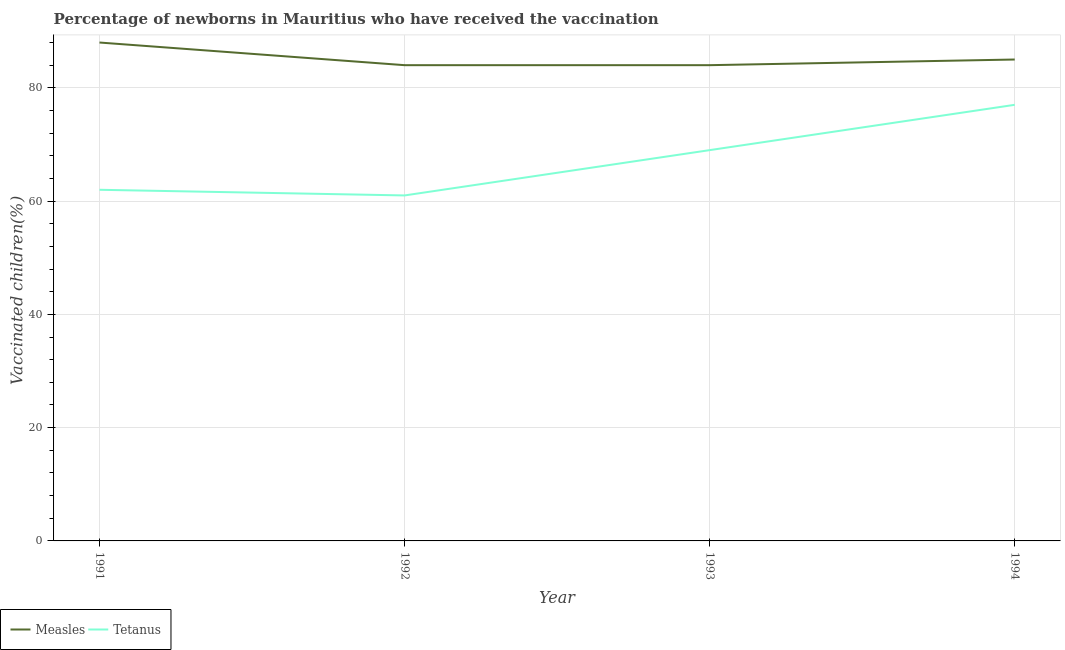How many different coloured lines are there?
Provide a succinct answer. 2. Does the line corresponding to percentage of newborns who received vaccination for measles intersect with the line corresponding to percentage of newborns who received vaccination for tetanus?
Your response must be concise. No. What is the percentage of newborns who received vaccination for measles in 1992?
Give a very brief answer. 84. Across all years, what is the maximum percentage of newborns who received vaccination for tetanus?
Ensure brevity in your answer.  77. Across all years, what is the minimum percentage of newborns who received vaccination for tetanus?
Ensure brevity in your answer.  61. What is the total percentage of newborns who received vaccination for measles in the graph?
Offer a very short reply. 341. What is the difference between the percentage of newborns who received vaccination for measles in 1991 and that in 1993?
Your answer should be compact. 4. What is the difference between the percentage of newborns who received vaccination for measles in 1994 and the percentage of newborns who received vaccination for tetanus in 1992?
Offer a terse response. 24. What is the average percentage of newborns who received vaccination for tetanus per year?
Provide a succinct answer. 67.25. In the year 1992, what is the difference between the percentage of newborns who received vaccination for measles and percentage of newborns who received vaccination for tetanus?
Give a very brief answer. 23. What is the ratio of the percentage of newborns who received vaccination for tetanus in 1991 to that in 1994?
Keep it short and to the point. 0.81. Is the percentage of newborns who received vaccination for measles in 1991 less than that in 1992?
Provide a succinct answer. No. Is the difference between the percentage of newborns who received vaccination for measles in 1991 and 1993 greater than the difference between the percentage of newborns who received vaccination for tetanus in 1991 and 1993?
Offer a terse response. Yes. What is the difference between the highest and the second highest percentage of newborns who received vaccination for tetanus?
Make the answer very short. 8. What is the difference between the highest and the lowest percentage of newborns who received vaccination for tetanus?
Make the answer very short. 16. In how many years, is the percentage of newborns who received vaccination for measles greater than the average percentage of newborns who received vaccination for measles taken over all years?
Make the answer very short. 1. Is the sum of the percentage of newborns who received vaccination for measles in 1992 and 1993 greater than the maximum percentage of newborns who received vaccination for tetanus across all years?
Your answer should be compact. Yes. Is the percentage of newborns who received vaccination for tetanus strictly less than the percentage of newborns who received vaccination for measles over the years?
Offer a terse response. Yes. How many lines are there?
Keep it short and to the point. 2. How many years are there in the graph?
Give a very brief answer. 4. What is the difference between two consecutive major ticks on the Y-axis?
Provide a short and direct response. 20. Where does the legend appear in the graph?
Your response must be concise. Bottom left. How many legend labels are there?
Ensure brevity in your answer.  2. How are the legend labels stacked?
Provide a succinct answer. Horizontal. What is the title of the graph?
Provide a short and direct response. Percentage of newborns in Mauritius who have received the vaccination. What is the label or title of the Y-axis?
Provide a short and direct response. Vaccinated children(%)
. What is the Vaccinated children(%)
 in Tetanus in 1991?
Make the answer very short. 62. What is the Vaccinated children(%)
 in Measles in 1992?
Provide a short and direct response. 84. What is the Vaccinated children(%)
 of Tetanus in 1994?
Provide a succinct answer. 77. Across all years, what is the maximum Vaccinated children(%)
 in Measles?
Offer a terse response. 88. Across all years, what is the maximum Vaccinated children(%)
 in Tetanus?
Make the answer very short. 77. Across all years, what is the minimum Vaccinated children(%)
 of Measles?
Offer a very short reply. 84. Across all years, what is the minimum Vaccinated children(%)
 of Tetanus?
Provide a short and direct response. 61. What is the total Vaccinated children(%)
 of Measles in the graph?
Provide a succinct answer. 341. What is the total Vaccinated children(%)
 of Tetanus in the graph?
Offer a very short reply. 269. What is the difference between the Vaccinated children(%)
 in Measles in 1991 and that in 1992?
Give a very brief answer. 4. What is the difference between the Vaccinated children(%)
 of Tetanus in 1991 and that in 1992?
Your response must be concise. 1. What is the difference between the Vaccinated children(%)
 of Measles in 1991 and that in 1993?
Your response must be concise. 4. What is the difference between the Vaccinated children(%)
 of Measles in 1991 and that in 1994?
Provide a short and direct response. 3. What is the difference between the Vaccinated children(%)
 of Measles in 1992 and that in 1993?
Make the answer very short. 0. What is the difference between the Vaccinated children(%)
 in Tetanus in 1992 and that in 1993?
Provide a succinct answer. -8. What is the difference between the Vaccinated children(%)
 in Measles in 1992 and that in 1994?
Ensure brevity in your answer.  -1. What is the difference between the Vaccinated children(%)
 in Measles in 1993 and that in 1994?
Provide a short and direct response. -1. What is the difference between the Vaccinated children(%)
 of Tetanus in 1993 and that in 1994?
Your answer should be compact. -8. What is the difference between the Vaccinated children(%)
 in Measles in 1991 and the Vaccinated children(%)
 in Tetanus in 1994?
Make the answer very short. 11. What is the difference between the Vaccinated children(%)
 of Measles in 1992 and the Vaccinated children(%)
 of Tetanus in 1993?
Provide a short and direct response. 15. What is the difference between the Vaccinated children(%)
 in Measles in 1992 and the Vaccinated children(%)
 in Tetanus in 1994?
Give a very brief answer. 7. What is the average Vaccinated children(%)
 of Measles per year?
Ensure brevity in your answer.  85.25. What is the average Vaccinated children(%)
 of Tetanus per year?
Your response must be concise. 67.25. In the year 1994, what is the difference between the Vaccinated children(%)
 in Measles and Vaccinated children(%)
 in Tetanus?
Provide a short and direct response. 8. What is the ratio of the Vaccinated children(%)
 of Measles in 1991 to that in 1992?
Keep it short and to the point. 1.05. What is the ratio of the Vaccinated children(%)
 in Tetanus in 1991 to that in 1992?
Offer a very short reply. 1.02. What is the ratio of the Vaccinated children(%)
 in Measles in 1991 to that in 1993?
Ensure brevity in your answer.  1.05. What is the ratio of the Vaccinated children(%)
 in Tetanus in 1991 to that in 1993?
Your answer should be compact. 0.9. What is the ratio of the Vaccinated children(%)
 in Measles in 1991 to that in 1994?
Your response must be concise. 1.04. What is the ratio of the Vaccinated children(%)
 of Tetanus in 1991 to that in 1994?
Offer a terse response. 0.81. What is the ratio of the Vaccinated children(%)
 of Tetanus in 1992 to that in 1993?
Provide a succinct answer. 0.88. What is the ratio of the Vaccinated children(%)
 in Measles in 1992 to that in 1994?
Ensure brevity in your answer.  0.99. What is the ratio of the Vaccinated children(%)
 in Tetanus in 1992 to that in 1994?
Your response must be concise. 0.79. What is the ratio of the Vaccinated children(%)
 of Tetanus in 1993 to that in 1994?
Give a very brief answer. 0.9. What is the difference between the highest and the second highest Vaccinated children(%)
 of Tetanus?
Your response must be concise. 8. What is the difference between the highest and the lowest Vaccinated children(%)
 of Measles?
Offer a very short reply. 4. 